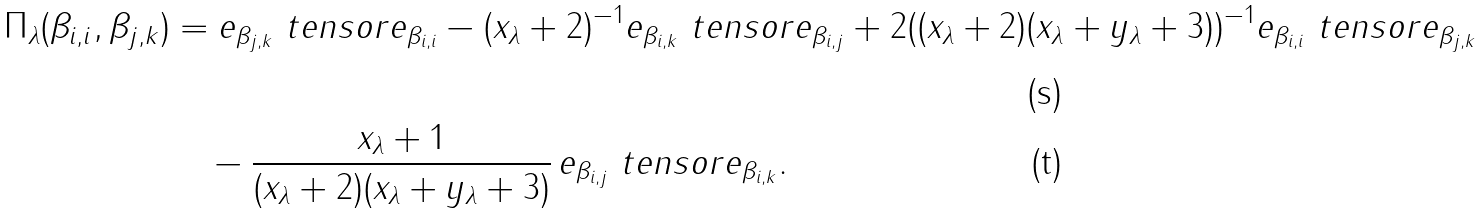Convert formula to latex. <formula><loc_0><loc_0><loc_500><loc_500>\Pi _ { \lambda } ( \beta _ { i , i } , \beta _ { j , k } ) & = e _ { \beta _ { j , k } } \ t e n s o r e _ { \beta _ { i , i } } - ( x _ { \lambda } + 2 ) ^ { - 1 } e _ { \beta _ { i , k } } \ t e n s o r e _ { \beta _ { i , j } } + 2 ( ( x _ { \lambda } + 2 ) ( x _ { \lambda } + y _ { \lambda } + 3 ) ) ^ { - 1 } e _ { \beta _ { i , i } } \ t e n s o r e _ { \beta _ { j , k } } \\ & \quad - \frac { x _ { \lambda } + 1 } { ( x _ { \lambda } + 2 ) ( x _ { \lambda } + y _ { \lambda } + 3 ) } \, e _ { \beta _ { i , j } } \ t e n s o r e _ { \beta _ { i , k } } .</formula> 